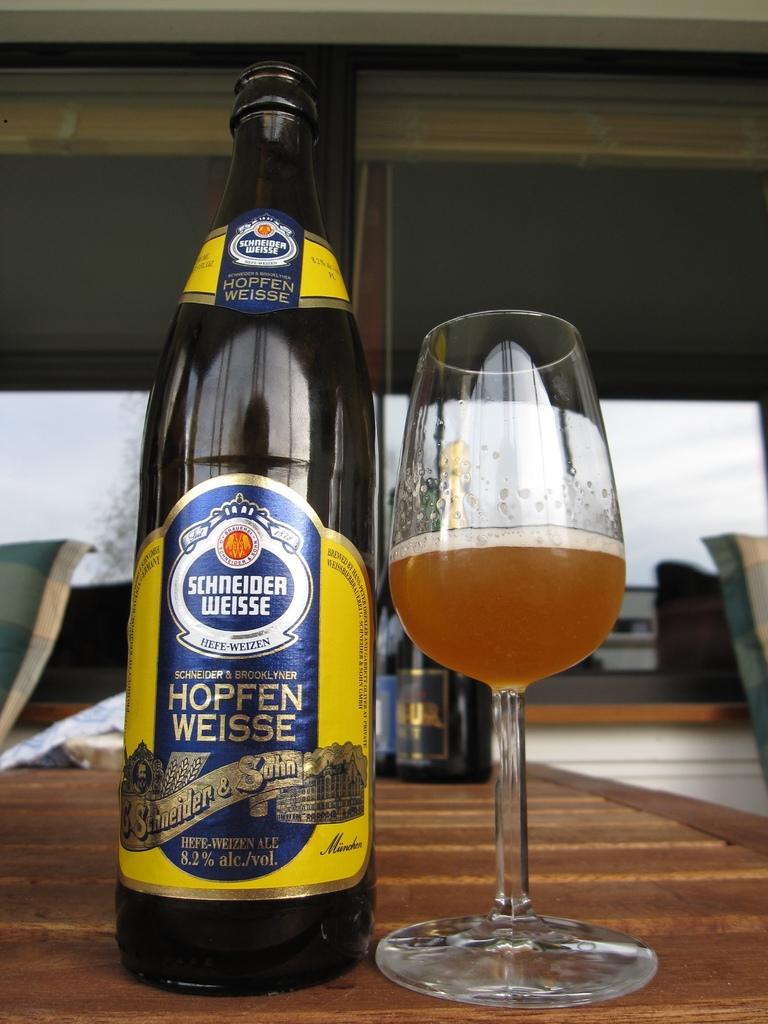What type of beer is this?
Your response must be concise. Hopfen weisse. 